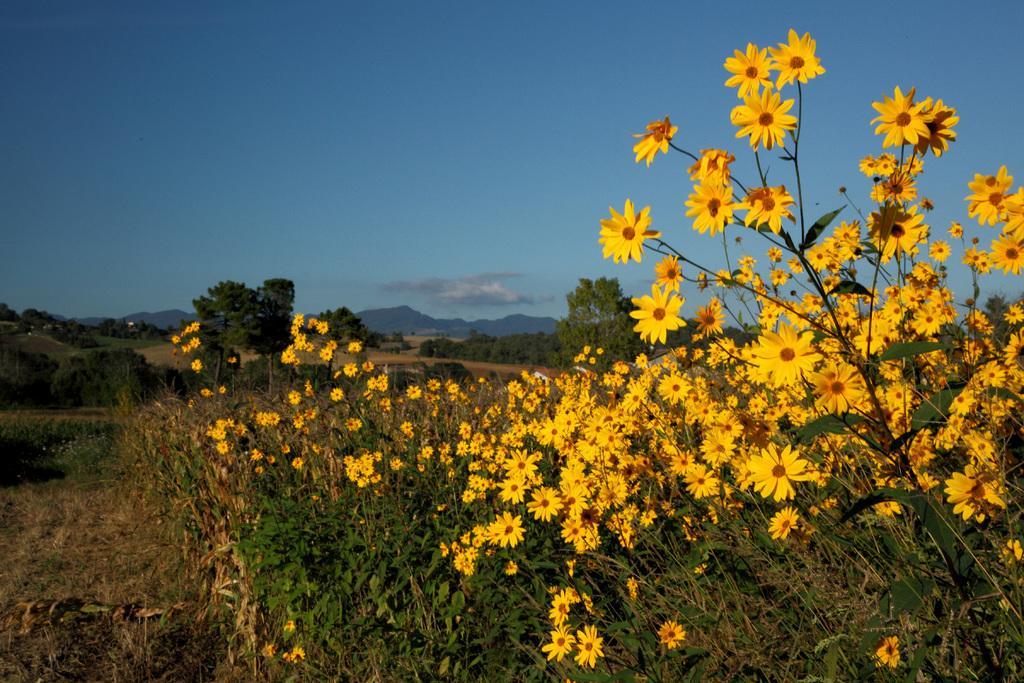Can you describe this image briefly? Here we can see plants with yellow color flowers. In the background there are trees,mountains and clouds in the sky. 